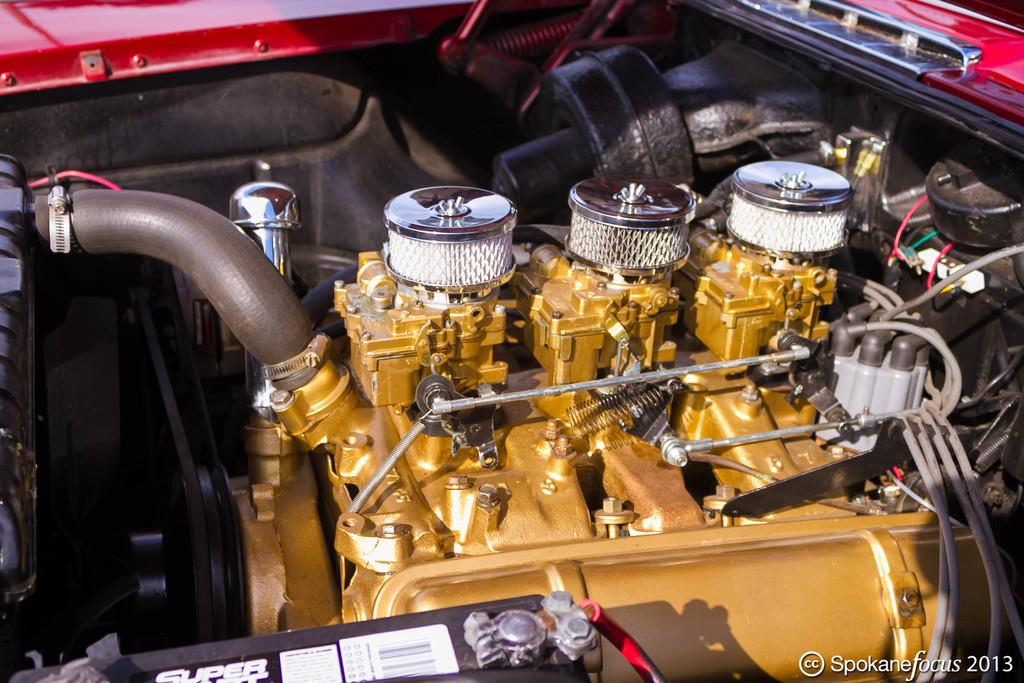What type of objects are featured in the image? The image contains vehicle engine parts. Can you describe any additional elements in the image? Yes, there is a logo on the right side bottom of the image. Are there any other markings or features in the image? Yes, there is a watermark on the right side bottom of the image. What type of parcel can be seen in the image? There is no parcel present in the image; it features vehicle engine parts, a logo, and a watermark. Can you hear a whistle in the image? There is no sound or indication of a whistle in the image, as it is a static visual representation. 